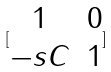Convert formula to latex. <formula><loc_0><loc_0><loc_500><loc_500>[ \begin{matrix} 1 & 0 \\ - s C & 1 \end{matrix} ]</formula> 